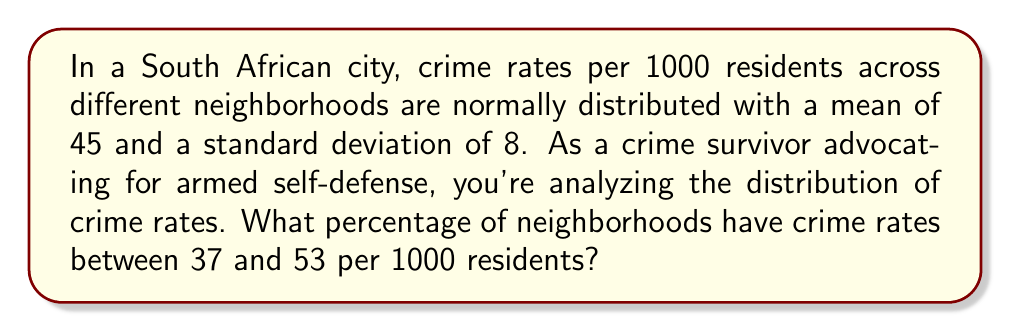Can you solve this math problem? Let's approach this step-by-step:

1) We're dealing with a normal distribution where:
   $\mu = 45$ (mean)
   $\sigma = 8$ (standard deviation)

2) We need to find the probability of a neighborhood having a crime rate between 37 and 53.

3) To do this, we need to calculate the z-scores for both 37 and 53:

   For 37: $z_1 = \frac{37 - 45}{8} = -1$
   For 53: $z_2 = \frac{53 - 45}{8} = 1$

4) Now, we need to find the area under the standard normal curve between z = -1 and z = 1.

5) Using the standard normal distribution table or a calculator:
   $P(-1 < Z < 1) = P(Z < 1) - P(Z < -1)$
                  $= 0.8413 - 0.1587$
                  $= 0.6826$

6) Convert to percentage: $0.6826 \times 100\% = 68.26\%$

This means that approximately 68.26% of neighborhoods have crime rates between 37 and 53 per 1000 residents.
Answer: 68.26% 